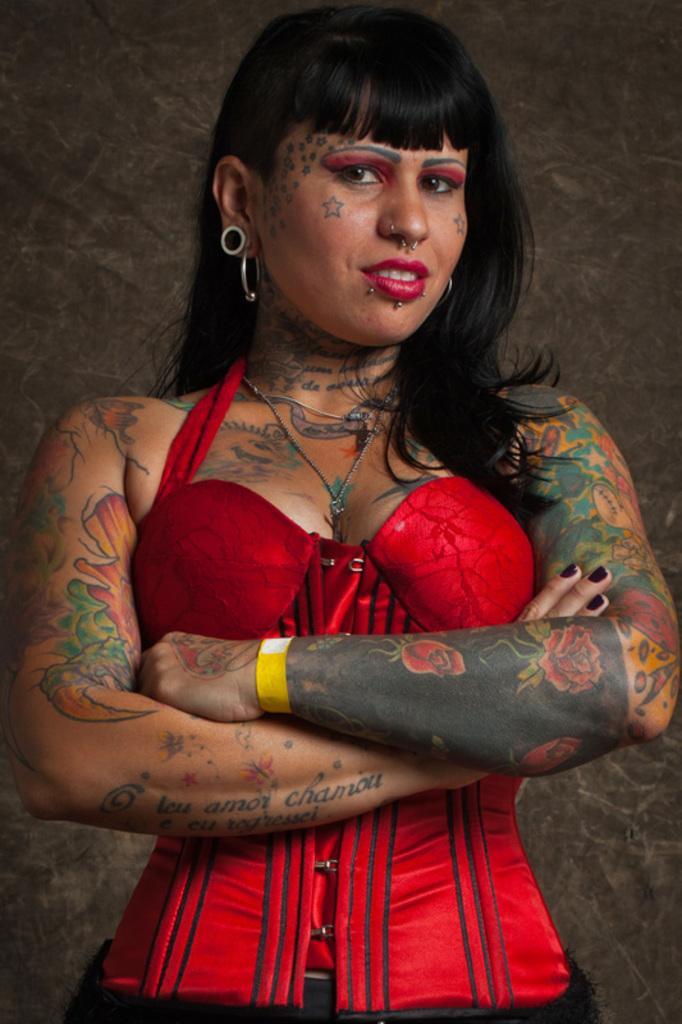Can you describe this image briefly? In this picture I can see a woman standing in front and I see that, she is wearing red and black color dress and I can see tattoos on her body. In the background I can see the brown color wall. 